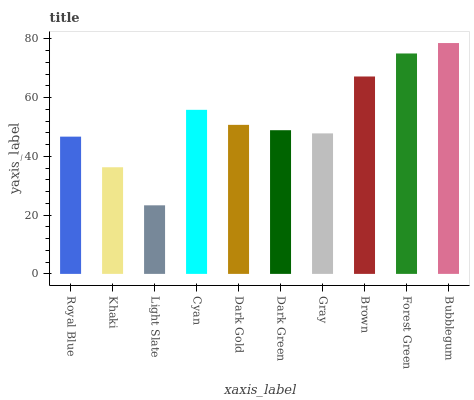Is Light Slate the minimum?
Answer yes or no. Yes. Is Bubblegum the maximum?
Answer yes or no. Yes. Is Khaki the minimum?
Answer yes or no. No. Is Khaki the maximum?
Answer yes or no. No. Is Royal Blue greater than Khaki?
Answer yes or no. Yes. Is Khaki less than Royal Blue?
Answer yes or no. Yes. Is Khaki greater than Royal Blue?
Answer yes or no. No. Is Royal Blue less than Khaki?
Answer yes or no. No. Is Dark Gold the high median?
Answer yes or no. Yes. Is Dark Green the low median?
Answer yes or no. Yes. Is Gray the high median?
Answer yes or no. No. Is Khaki the low median?
Answer yes or no. No. 